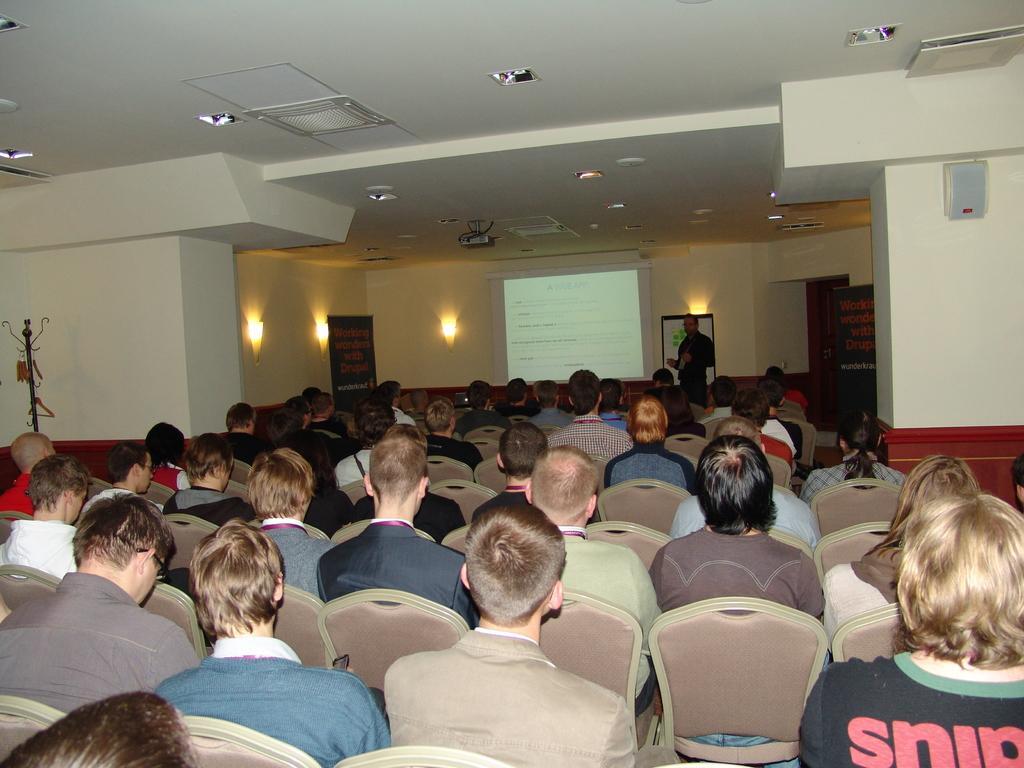Could you give a brief overview of what you see in this image? In this image, we can see some persons wearing clothes and sitting on chairs. There is a person standing beside the screen. There are some lights in the middle of the image. There is a ceiling at the top of the image. 